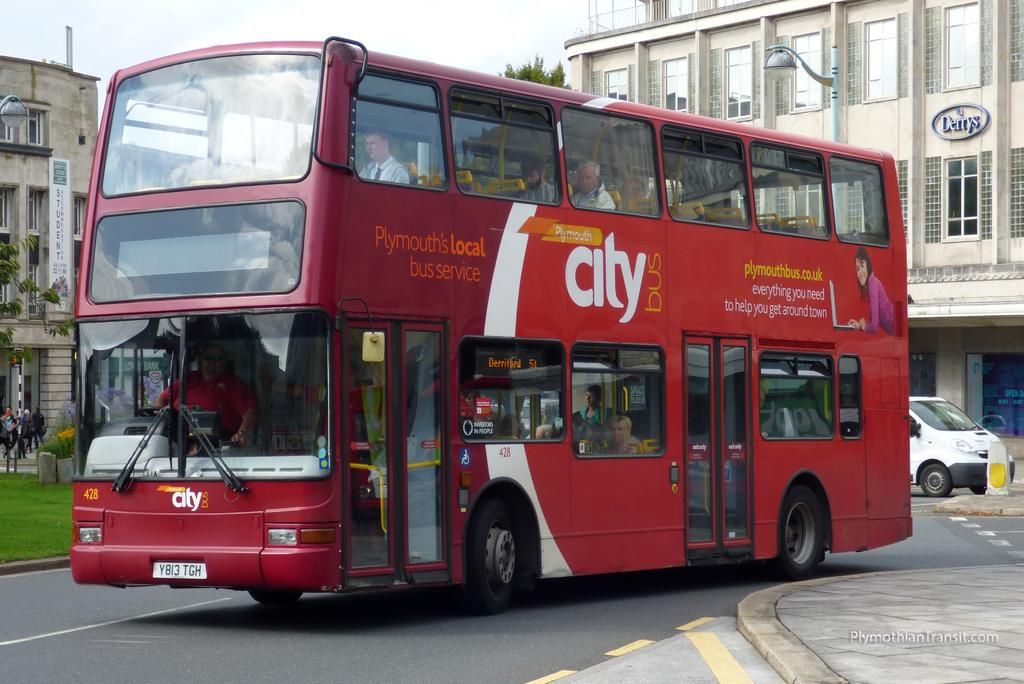<image>
Present a compact description of the photo's key features. A double-decker bus is red and has the words "city bus" painted on the side. 